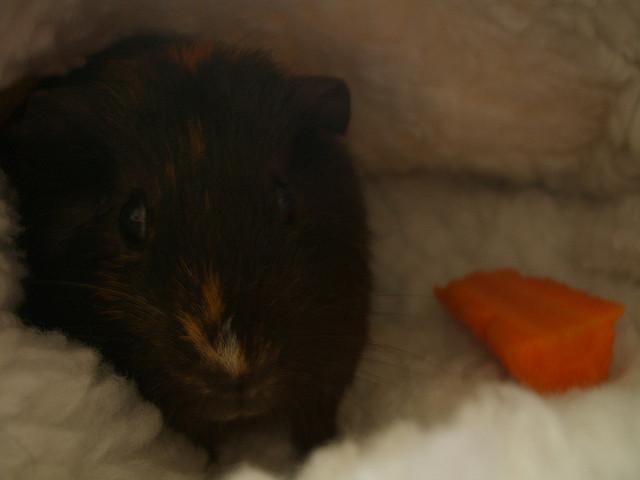Is the carrot to be placed on the snowman?
Quick response, please. No. What type of animal is this?
Quick response, please. Gerbil. Is the carrot for the animal to snack on?
Quick response, please. Yes. What is at the bottom right corner of this photo?
Be succinct. Carrot. Is the carrot too big?
Give a very brief answer. No. What animal is shown?
Concise answer only. Hamster. Is the animal a rodent?
Keep it brief. Yes. What color is the sleeping animal?
Give a very brief answer. Brown. What color is the dog?
Be succinct. Black. 